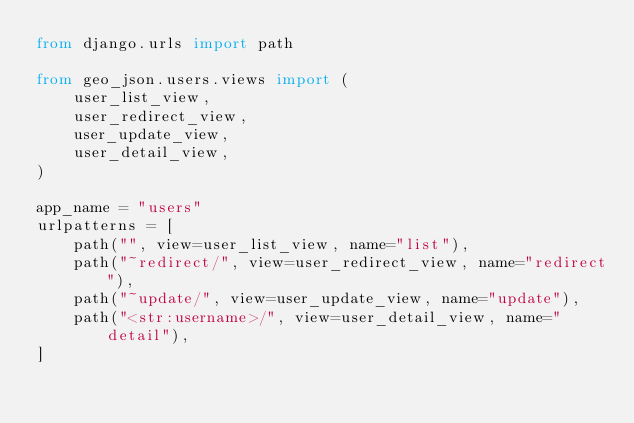<code> <loc_0><loc_0><loc_500><loc_500><_Python_>from django.urls import path

from geo_json.users.views import (
    user_list_view,
    user_redirect_view,
    user_update_view,
    user_detail_view,
)

app_name = "users"
urlpatterns = [
    path("", view=user_list_view, name="list"),
    path("~redirect/", view=user_redirect_view, name="redirect"),
    path("~update/", view=user_update_view, name="update"),
    path("<str:username>/", view=user_detail_view, name="detail"),
]
</code> 